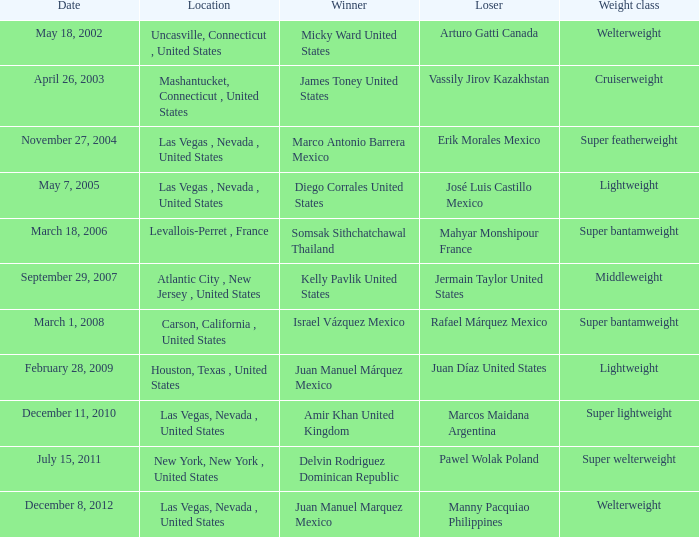What was the duration of the lightweight class up until february 28, 2009? 1.0. 